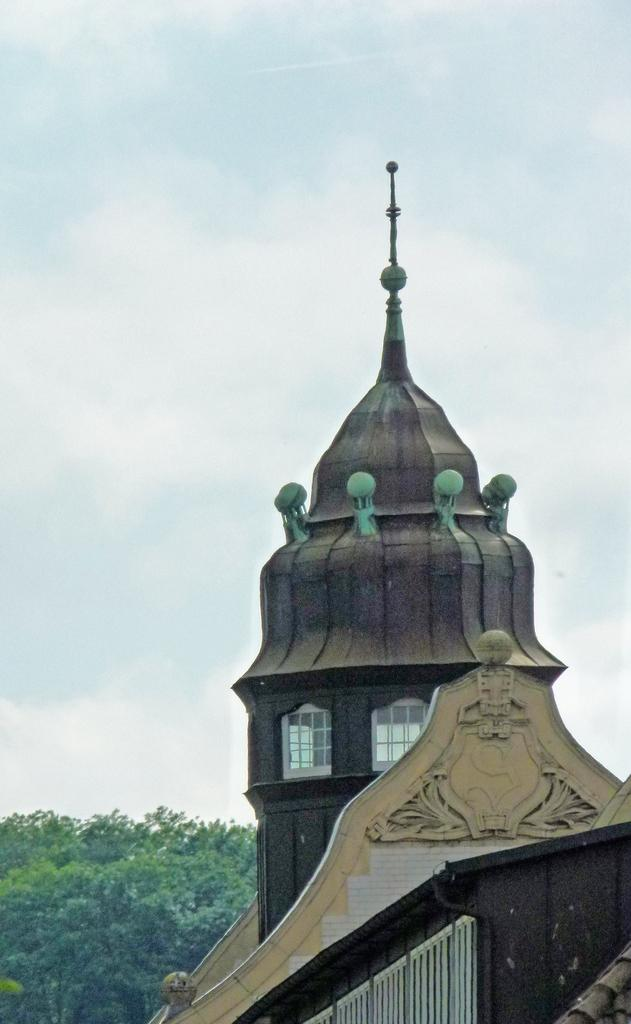What is located at the bottom of the image? There is a building and trees at the bottom of the image. What can be seen in the sky at the top of the image? The sky is visible at the top of the image. What type of sofa can be seen in the image? There is no sofa present in the image. How does the angle of the building affect the acoustics in the image? There is no information about the angle of the building or its effect on acoustics in the image. 